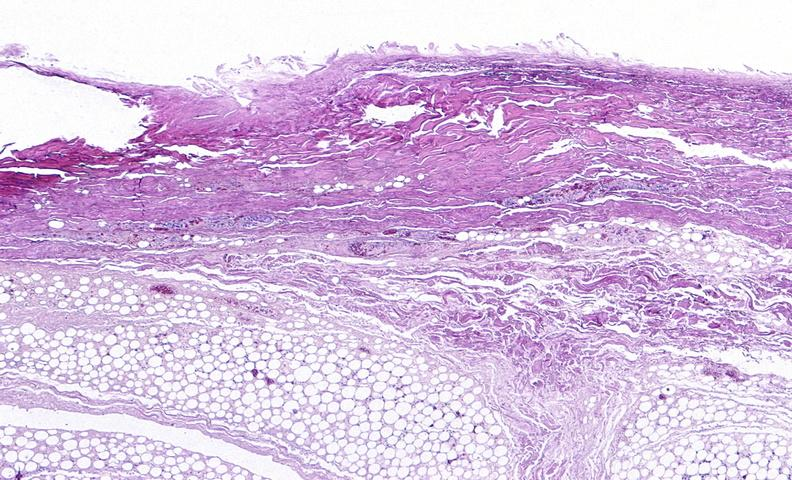where is this?
Answer the question using a single word or phrase. Skin 